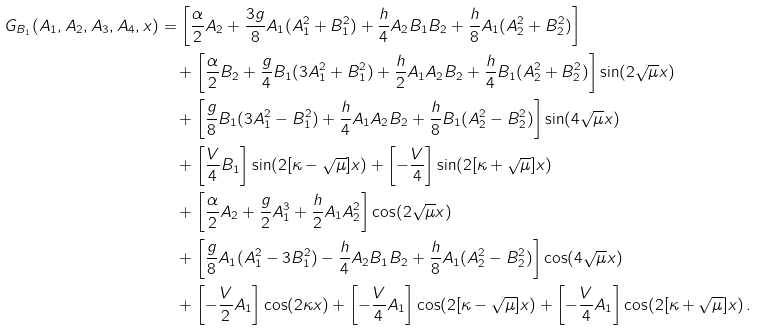Convert formula to latex. <formula><loc_0><loc_0><loc_500><loc_500>G _ { B _ { 1 } } ( A _ { 1 } , A _ { 2 } , A _ { 3 } , A _ { 4 } , x ) & = \left [ \frac { \alpha } { 2 } A _ { 2 } + \frac { 3 g } { 8 } A _ { 1 } ( A _ { 1 } ^ { 2 } + B _ { 1 } ^ { 2 } ) + \frac { h } { 4 } A _ { 2 } B _ { 1 } B _ { 2 } + \frac { h } { 8 } A _ { 1 } ( A _ { 2 } ^ { 2 } + B _ { 2 } ^ { 2 } ) \right ] \\ & \quad + \left [ \frac { \alpha } { 2 } B _ { 2 } + \frac { g } { 4 } B _ { 1 } ( 3 A _ { 1 } ^ { 2 } + B _ { 1 } ^ { 2 } ) + \frac { h } { 2 } A _ { 1 } A _ { 2 } B _ { 2 } + \frac { h } { 4 } B _ { 1 } ( A _ { 2 } ^ { 2 } + B _ { 2 } ^ { 2 } ) \right ] \sin ( 2 \sqrt { \mu } x ) \\ & \quad + \left [ \frac { g } { 8 } B _ { 1 } ( 3 A _ { 1 } ^ { 2 } - B _ { 1 } ^ { 2 } ) + \frac { h } { 4 } A _ { 1 } A _ { 2 } B _ { 2 } + \frac { h } { 8 } B _ { 1 } ( A _ { 2 } ^ { 2 } - B _ { 2 } ^ { 2 } ) \right ] \sin ( 4 \sqrt { \mu } x ) \\ & \quad + \left [ \frac { V } { 4 } B _ { 1 } \right ] \sin ( 2 [ \kappa - \sqrt { \mu } ] x ) + \left [ - \frac { V } { 4 } \right ] \sin ( 2 [ \kappa + \sqrt { \mu } ] x ) \\ & \quad + \left [ \frac { \alpha } { 2 } A _ { 2 } + \frac { g } { 2 } A _ { 1 } ^ { 3 } + \frac { h } { 2 } A _ { 1 } A _ { 2 } ^ { 2 } \right ] \cos ( 2 \sqrt { \mu } x ) \\ & \quad + \left [ \frac { g } { 8 } A _ { 1 } ( A _ { 1 } ^ { 2 } - 3 B _ { 1 } ^ { 2 } ) - \frac { h } { 4 } A _ { 2 } B _ { 1 } B _ { 2 } + \frac { h } { 8 } A _ { 1 } ( A _ { 2 } ^ { 2 } - B _ { 2 } ^ { 2 } ) \right ] \cos ( 4 \sqrt { \mu } x ) \\ & \quad + \left [ - \frac { V } { 2 } A _ { 1 } \right ] \cos ( 2 \kappa x ) + \left [ - \frac { V } { 4 } A _ { 1 } \right ] \cos ( 2 [ \kappa - \sqrt { \mu } ] x ) + \left [ - \frac { V } { 4 } A _ { 1 } \right ] \cos ( 2 [ \kappa + \sqrt { \mu } ] x ) \, .</formula> 